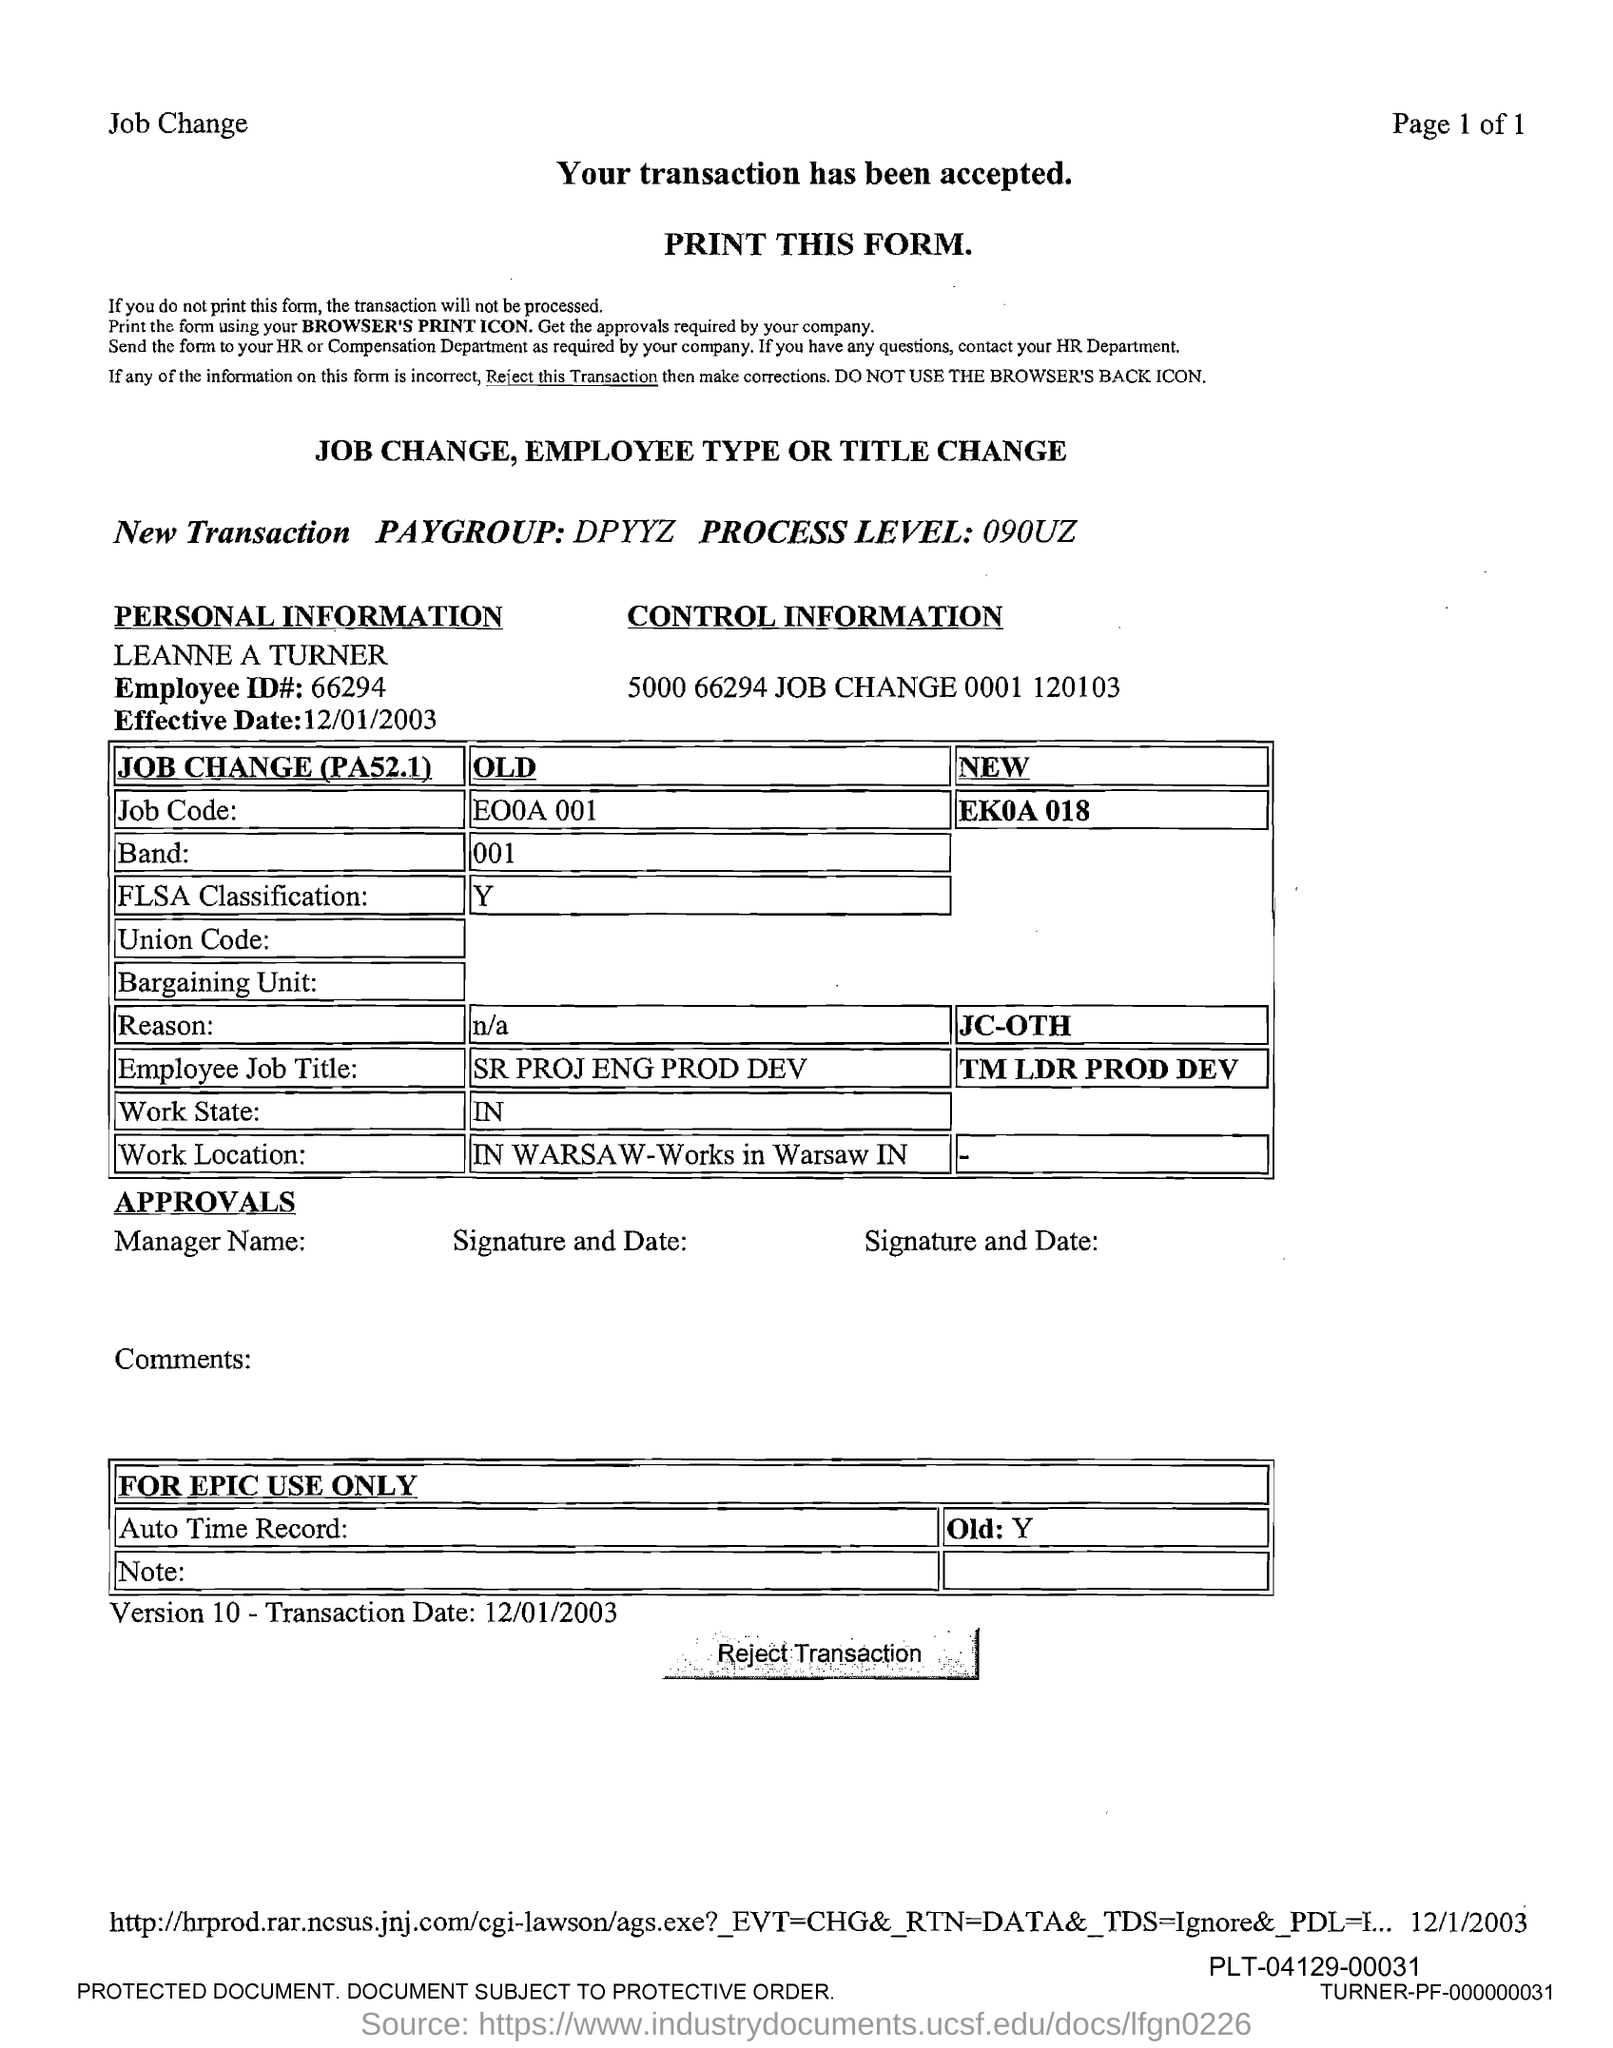What is the Employee id?
Give a very brief answer. 66294. 